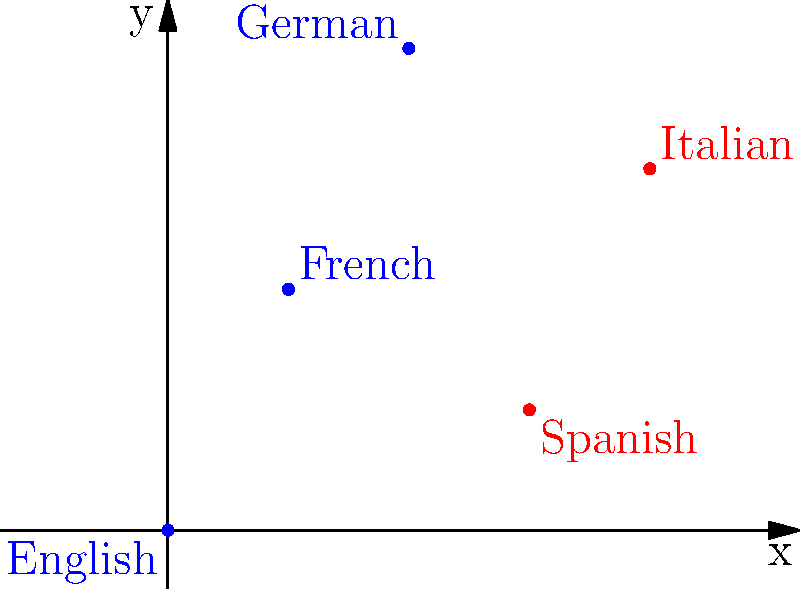In a coordinate plane representing musical notes in different languages, points are plotted as follows:
English (0,0), French (1,2), German (2,4), Spanish (3,1), and Italian (4,3).
What is the slope of the line connecting the points representing the Romance languages (French, Spanish, and Italian)? To find the slope of the line connecting the Romance languages, we'll use the slope formula:

$m = \frac{y_2 - y_1}{x_2 - x_1}$

1. Identify the coordinates of the Romance language points:
   French (1,2), Spanish (3,1), Italian (4,3)

2. Choose two points to calculate the slope. Let's use French (1,2) and Italian (4,3):
   $(x_1, y_1) = (1, 2)$
   $(x_2, y_2) = (4, 3)$

3. Apply the slope formula:
   $m = \frac{y_2 - y_1}{x_2 - x_1} = \frac{3 - 2}{4 - 1} = \frac{1}{3}$

4. Verify that the Spanish point (3,1) also lies on this line:
   Using the point-slope form: $y - y_1 = m(x - x_1)$
   Substituting: $y - 2 = \frac{1}{3}(x - 1)$
   For Spanish (3,1): $1 - 2 = \frac{1}{3}(3 - 1)$
   $-1 = \frac{2}{3}$ (This equation holds true)

Therefore, all three Romance language points lie on a line with a slope of $\frac{1}{3}$.
Answer: $\frac{1}{3}$ 